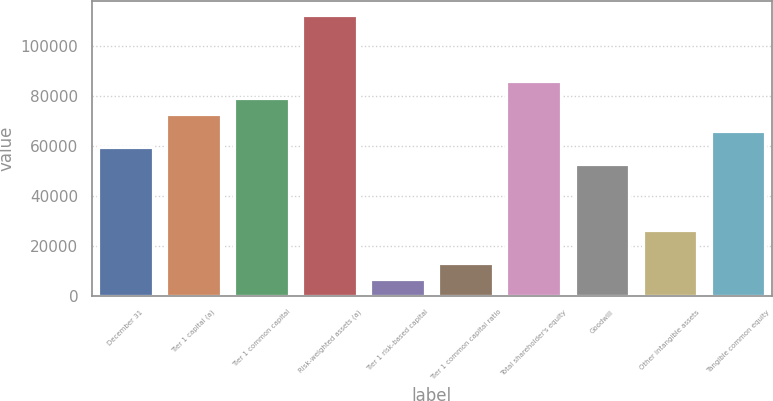<chart> <loc_0><loc_0><loc_500><loc_500><bar_chart><fcel>December 31<fcel>Tier 1 capital (a)<fcel>Tier 1 common capital<fcel>Risk-weighted assets (a)<fcel>Tier 1 risk-based capital<fcel>Tier 1 common capital ratio<fcel>Total shareholder's equity<fcel>Goodwill<fcel>Other intangible assets<fcel>Tangible common equity<nl><fcel>59504.4<fcel>72725.5<fcel>79336<fcel>112389<fcel>6620.28<fcel>13230.8<fcel>85946.5<fcel>52893.9<fcel>26451.8<fcel>66115<nl></chart> 